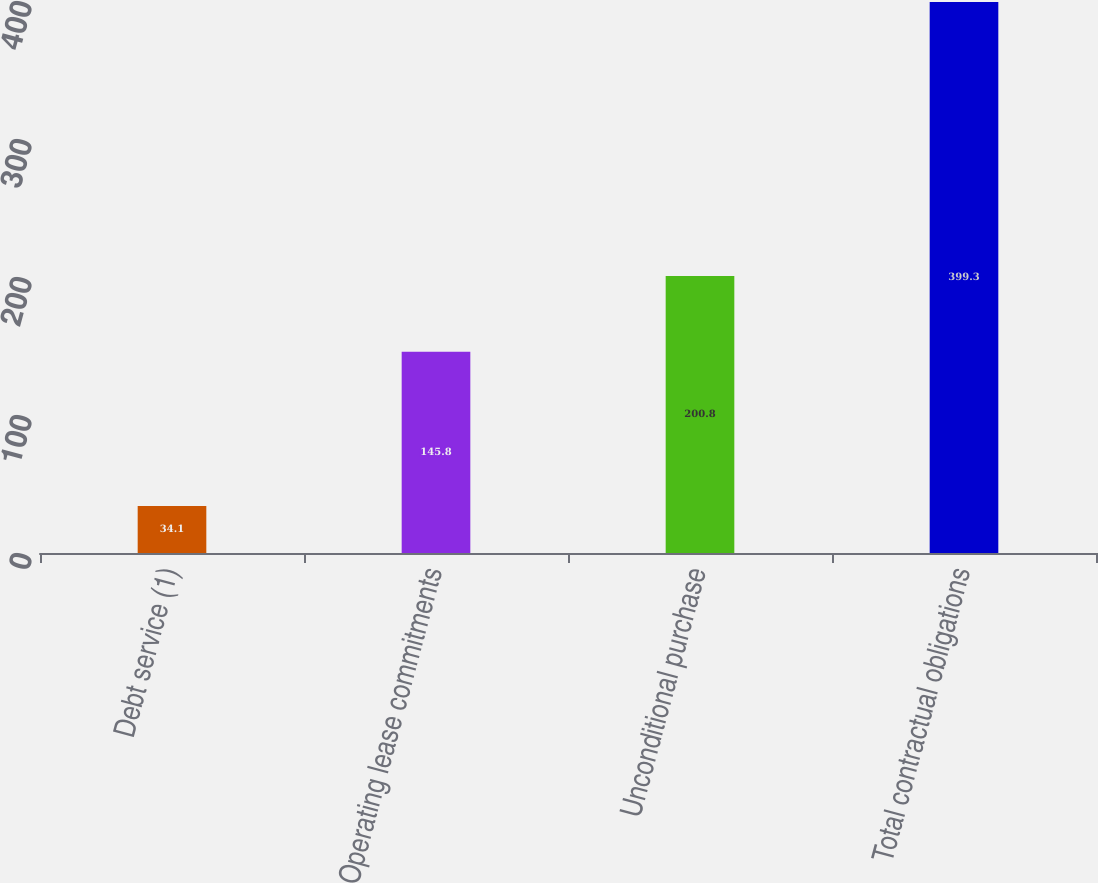<chart> <loc_0><loc_0><loc_500><loc_500><bar_chart><fcel>Debt service (1)<fcel>Operating lease commitments<fcel>Unconditional purchase<fcel>Total contractual obligations<nl><fcel>34.1<fcel>145.8<fcel>200.8<fcel>399.3<nl></chart> 